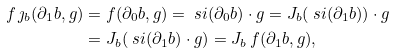Convert formula to latex. <formula><loc_0><loc_0><loc_500><loc_500>f \, \jmath _ { b } ( \partial _ { 1 } b , g ) & = f ( \partial _ { 0 } b , g ) = \ s i ( \partial _ { 0 } b ) \cdot g = J _ { b } ( \ s i ( \partial _ { 1 } b ) ) \cdot g \\ & = J _ { b } ( \ s i ( \partial _ { 1 } b ) \cdot g ) = J _ { b } \, f ( \partial _ { 1 } b , g ) ,</formula> 